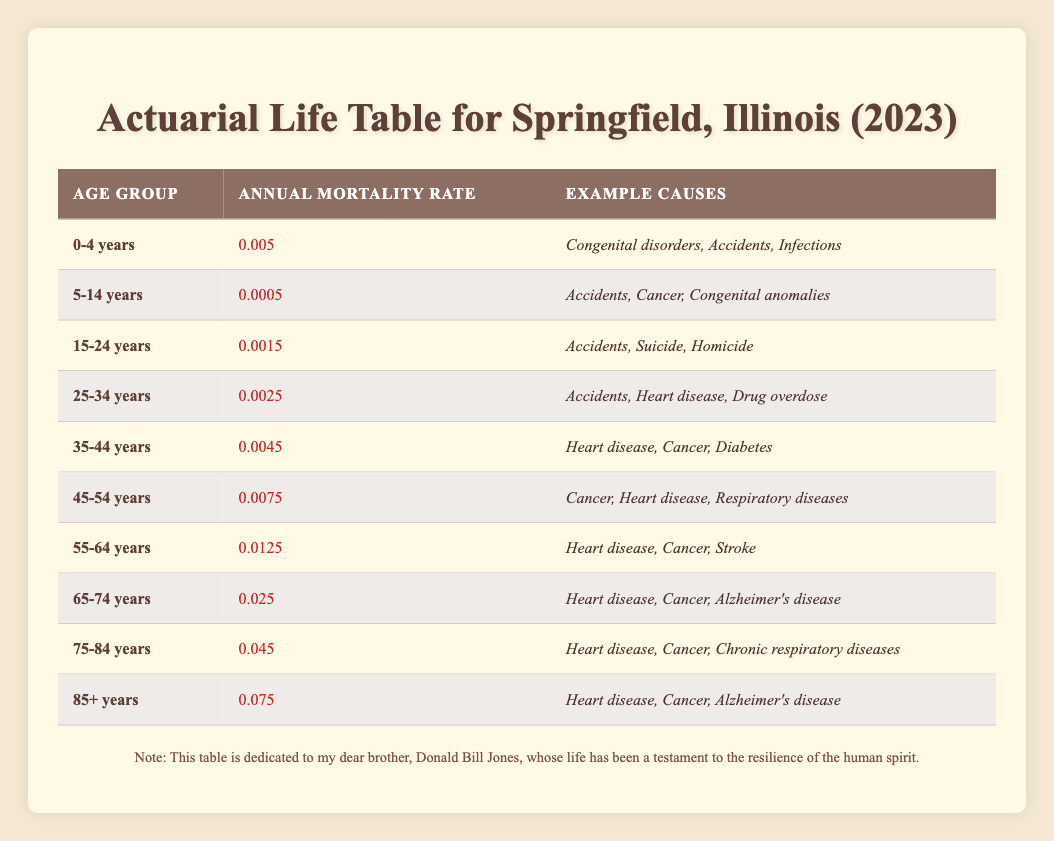What is the annual mortality rate for the age group 35-44 years? The table indicates that the annual mortality rate for the age group 35-44 years is listed directly under the "Annual Mortality Rate" column for that specific age group.
Answer: 0.0045 Which age group has the highest annual mortality rate? By examining the "Annual Mortality Rate" column, the age group 85+ years has the highest rate of 0.075, which is clearly the highest among all listed age groups.
Answer: 85+ years Is the annual mortality rate higher for the 45-54 age group compared to the 25-34 age group? The annual mortality rate for the 45-54 age group is 0.0075, while the rate for the 25-34 age group is 0.0025. Comparing these, 0.0075 is greater than 0.0025.
Answer: Yes What is the average annual mortality rate for age groups 0-4 and 5-14 years? The annual mortality rates for these groups are 0.005 and 0.0005, respectively. Adding these two rates gives 0.005 + 0.0005 = 0.0055. The average is then calculated by dividing this sum by 2, so 0.0055 / 2 = 0.00275.
Answer: 0.00275 For which age group are the example causes primarily related to cancer and heart disease? By reviewing the "Example Causes" column for each age group, it can be seen that the 45-54 years, 55-64 years, 65-74 years, 75-84 years, and 85+ years groups all list cancer and heart disease as main causes. Specifically, 45-54 years, 55-64 years, 65-74 years, 75-84 years, and 85+ years feature both conditions.
Answer: 45-54, 55-64, 65-74, 75-84, 85+ years What is the combined annual mortality rate for the age groups 0-4 years and 5-14 years? The annual mortality rates for these two groups are 0.005 and 0.0005. Adding these gives a combined rate of 0.005 + 0.0005 = 0.0055.
Answer: 0.0055 Does the age group 15-24 years have a higher annual mortality rate than the age group 5-14 years? The age group 15-24 years has an annual mortality rate of 0.0015, while the age group 5-14 years has a rate of 0.0005. Comparing these, 0.0015 is greater than 0.0005.
Answer: Yes Which age group has cancer as a cause of mortality? Scanning the "Example Causes" column, cancer appears as a cause for the groups 45-54 years, 55-64 years, 65-74 years, 75-84 years, and 85+ years.
Answer: 45-54, 55-64, 65-74, 75-84, 85+ years 